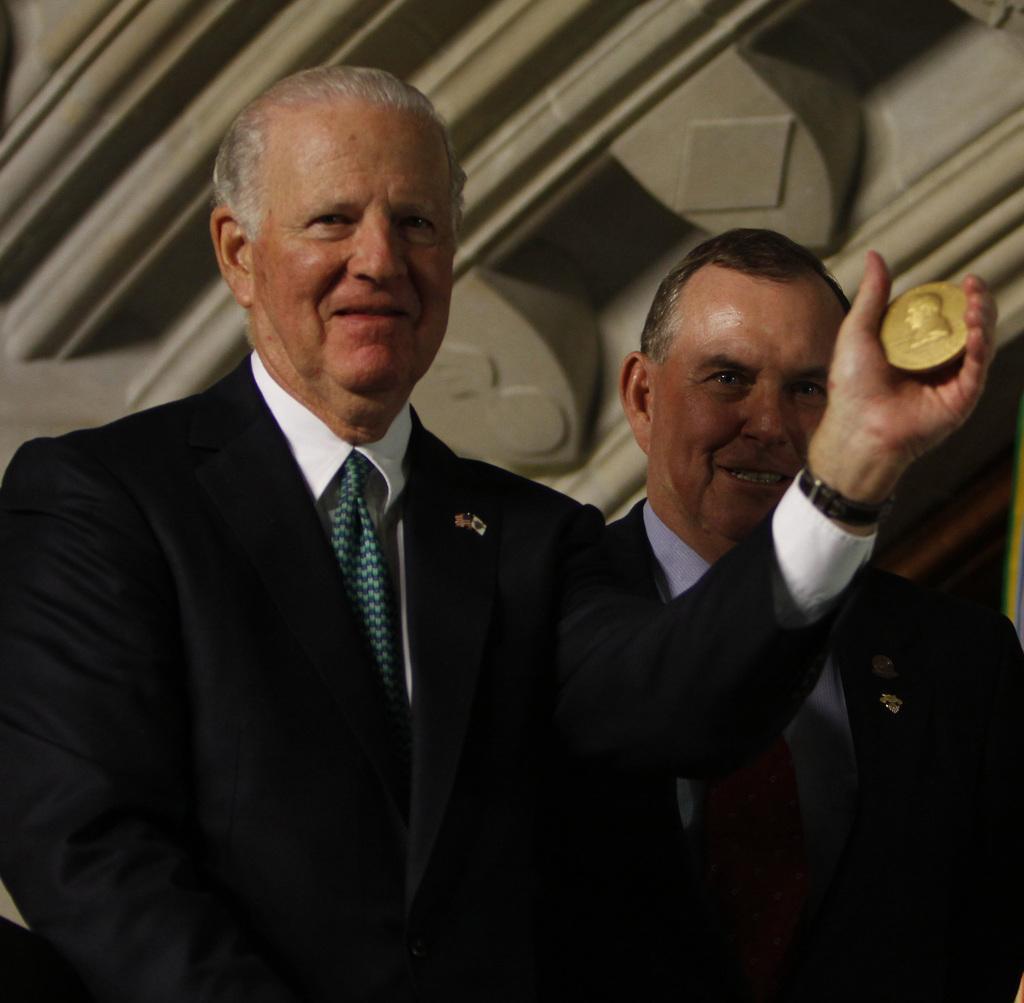Please provide a concise description of this image. In this image, we can see two men. In the middle, we can also see a man holding an object in his hand. At the top, we can see a metal roof. 